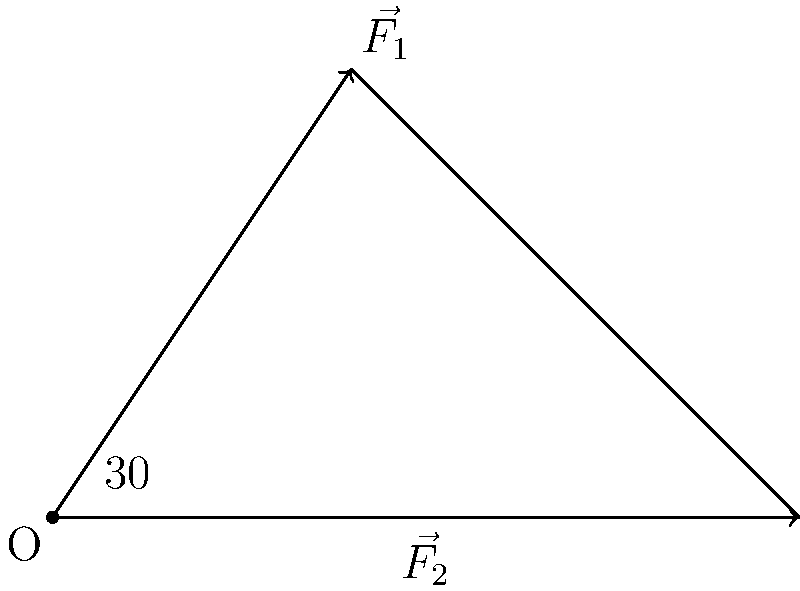In a simplified muscle-bone system, two forces $\vec{F_1}$ and $\vec{F_2}$ act on a joint as shown in the diagram. $\vec{F_1}$ has a magnitude of 100 N and makes an angle of 30° with the horizontal. $\vec{F_2}$ has a magnitude of 150 N and acts horizontally. Calculate the magnitude of the resultant force vector acting on the joint. To solve this problem, we'll follow these steps:

1) First, let's break down the forces into their x and y components:

   For $\vec{F_1}$:
   $F_{1x} = 100 \cos 30° = 100 \cdot \frac{\sqrt{3}}{2} = 50\sqrt{3}$ N
   $F_{1y} = 100 \sin 30° = 100 \cdot \frac{1}{2} = 50$ N

   For $\vec{F_2}$:
   $F_{2x} = 150$ N
   $F_{2y} = 0$ N (as it's horizontal)

2) Now, we'll sum the x and y components separately:

   $F_x = F_{1x} + F_{2x} = 50\sqrt{3} + 150$ N
   $F_y = F_{1y} + F_{2y} = 50 + 0 = 50$ N

3) The resultant force vector $\vec{R}$ will have these x and y components. To find its magnitude, we use the Pythagorean theorem:

   $|\vec{R}| = \sqrt{F_x^2 + F_y^2}$

4) Substituting the values:

   $|\vec{R}| = \sqrt{(50\sqrt{3} + 150)^2 + 50^2}$

5) Simplifying inside the square root:

   $|\vec{R}| = \sqrt{(86.6 + 150)^2 + 50^2} = \sqrt{236.6^2 + 50^2}$

6) Calculating the final result:

   $|\vec{R}| = \sqrt{55979.56 + 2500} = \sqrt{58479.56} \approx 241.82$ N
Answer: 241.82 N 